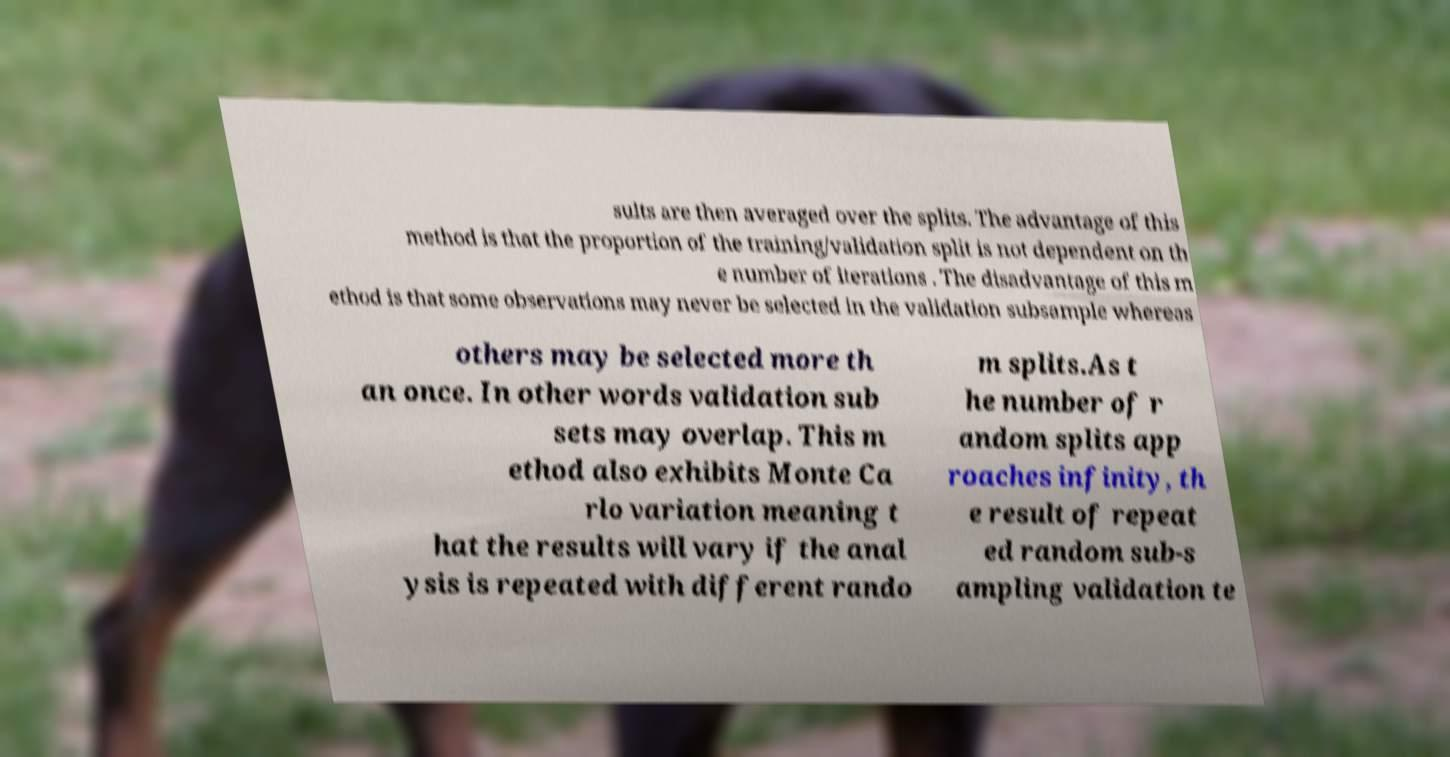For documentation purposes, I need the text within this image transcribed. Could you provide that? sults are then averaged over the splits. The advantage of this method is that the proportion of the training/validation split is not dependent on th e number of iterations . The disadvantage of this m ethod is that some observations may never be selected in the validation subsample whereas others may be selected more th an once. In other words validation sub sets may overlap. This m ethod also exhibits Monte Ca rlo variation meaning t hat the results will vary if the anal ysis is repeated with different rando m splits.As t he number of r andom splits app roaches infinity, th e result of repeat ed random sub-s ampling validation te 